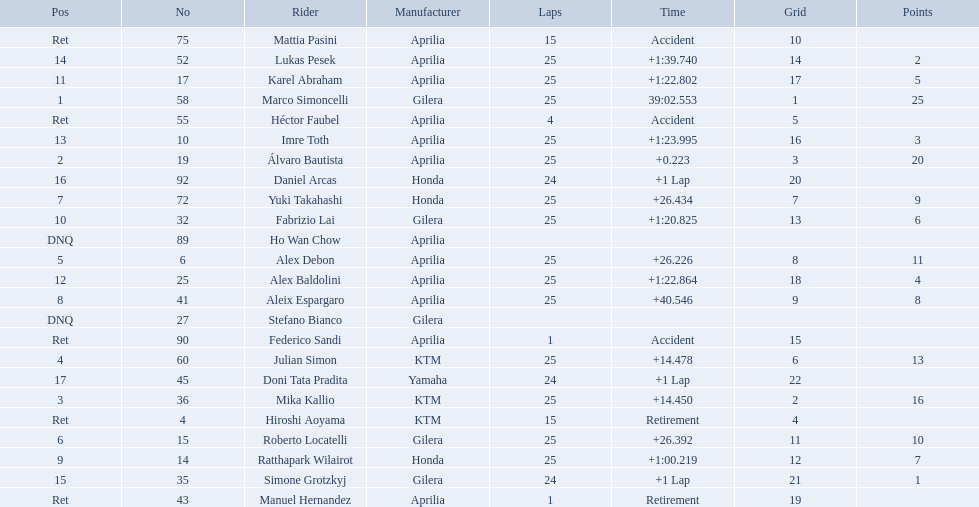What was the fastest overall time? 39:02.553. Who does this time belong to? Marco Simoncelli. Who were all of the riders? Marco Simoncelli, Álvaro Bautista, Mika Kallio, Julian Simon, Alex Debon, Roberto Locatelli, Yuki Takahashi, Aleix Espargaro, Ratthapark Wilairot, Fabrizio Lai, Karel Abraham, Alex Baldolini, Imre Toth, Lukas Pesek, Simone Grotzkyj, Daniel Arcas, Doni Tata Pradita, Hiroshi Aoyama, Mattia Pasini, Héctor Faubel, Federico Sandi, Manuel Hernandez, Stefano Bianco, Ho Wan Chow. How many laps did they complete? 25, 25, 25, 25, 25, 25, 25, 25, 25, 25, 25, 25, 25, 25, 24, 24, 24, 15, 15, 4, 1, 1, , . Between marco simoncelli and hiroshi aoyama, who had more laps? Marco Simoncelli. 